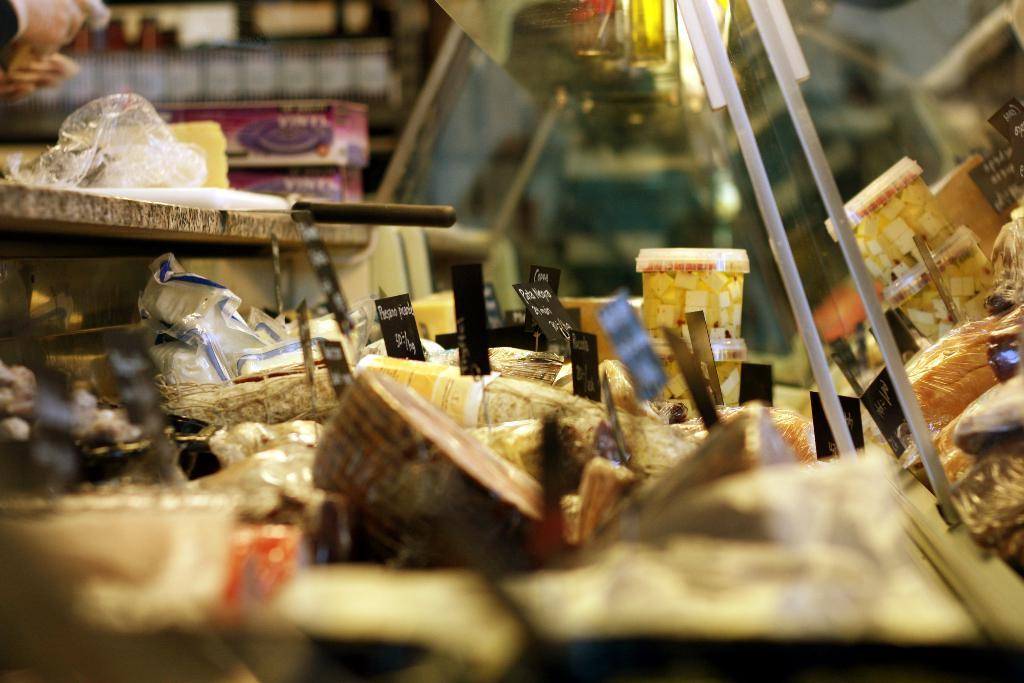Can you describe the items present in the image from top to bottom? There are various items present in the image from top to bottom, but without specific details, it's difficult to provide a comprehensive description. How many drawers are visible in the image? There is no mention of a drawer in the provided facts, so it cannot be determined from the image. 